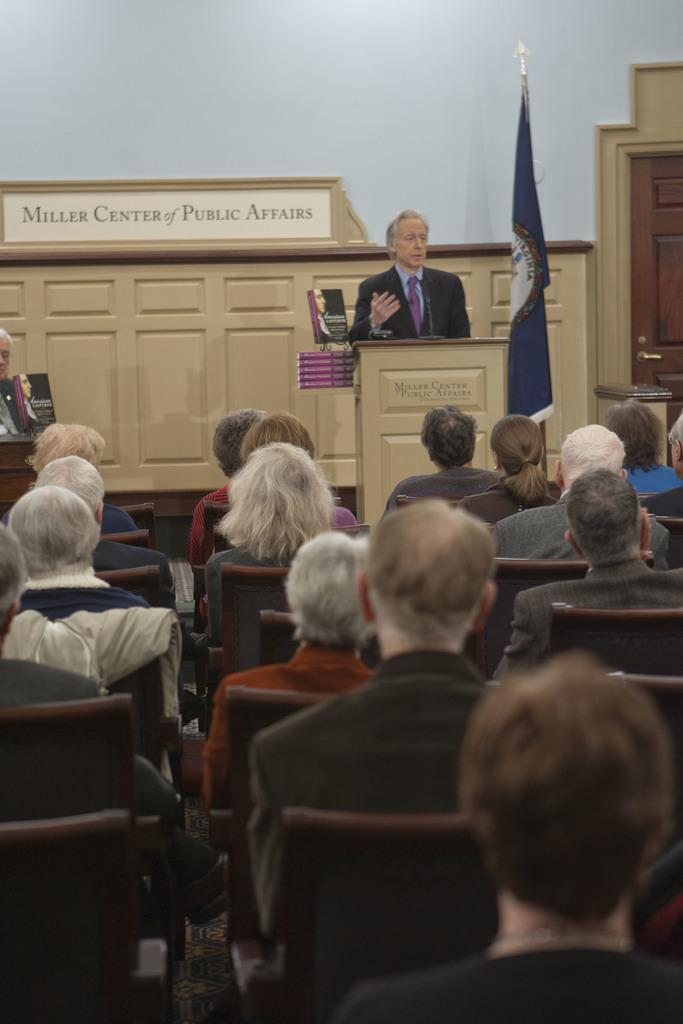What are the people in the image doing? The people in the image are sitting on chairs. What is the man standing next to in the image? The man is standing next to a podium in the image. What can be seen in the background or foreground of the image? There is a flag visible in the image. What type of bulb is hanging from the ceiling in the image? There is no bulb visible in the image. Can you solve the riddle that is written on the podium in the image? There is no riddle present in the image; there is only a man standing next to the podium. 